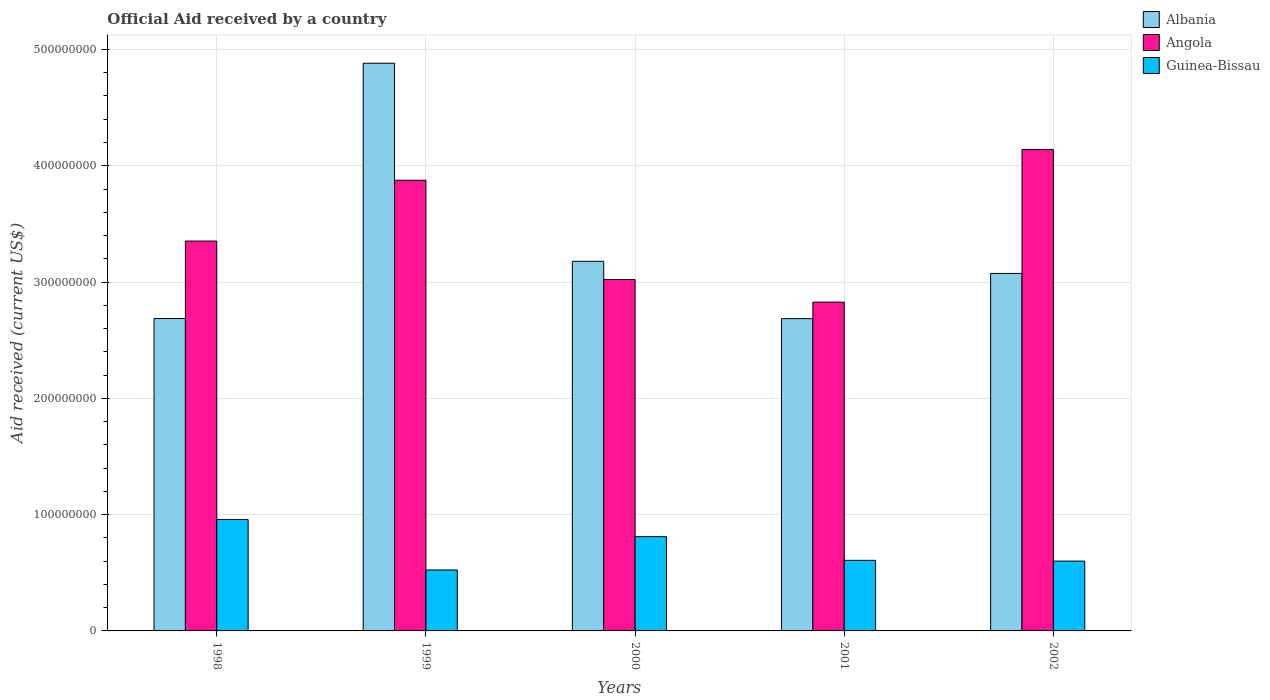Are the number of bars per tick equal to the number of legend labels?
Your answer should be compact. Yes. Are the number of bars on each tick of the X-axis equal?
Offer a terse response. Yes. What is the label of the 2nd group of bars from the left?
Give a very brief answer. 1999. What is the net official aid received in Angola in 2001?
Make the answer very short. 2.83e+08. Across all years, what is the maximum net official aid received in Angola?
Offer a very short reply. 4.14e+08. Across all years, what is the minimum net official aid received in Guinea-Bissau?
Offer a very short reply. 5.24e+07. In which year was the net official aid received in Angola maximum?
Your answer should be very brief. 2002. In which year was the net official aid received in Angola minimum?
Your response must be concise. 2001. What is the total net official aid received in Angola in the graph?
Offer a terse response. 1.72e+09. What is the difference between the net official aid received in Albania in 2001 and that in 2002?
Provide a short and direct response. -3.89e+07. What is the difference between the net official aid received in Albania in 2001 and the net official aid received in Angola in 1999?
Your response must be concise. -1.19e+08. What is the average net official aid received in Albania per year?
Make the answer very short. 3.30e+08. In the year 1998, what is the difference between the net official aid received in Angola and net official aid received in Albania?
Provide a succinct answer. 6.66e+07. What is the ratio of the net official aid received in Albania in 2000 to that in 2001?
Provide a short and direct response. 1.18. What is the difference between the highest and the second highest net official aid received in Angola?
Your answer should be very brief. 2.65e+07. What is the difference between the highest and the lowest net official aid received in Albania?
Offer a very short reply. 2.20e+08. In how many years, is the net official aid received in Albania greater than the average net official aid received in Albania taken over all years?
Keep it short and to the point. 1. Is the sum of the net official aid received in Guinea-Bissau in 1999 and 2001 greater than the maximum net official aid received in Albania across all years?
Offer a very short reply. No. What does the 1st bar from the left in 2000 represents?
Offer a terse response. Albania. What does the 3rd bar from the right in 2002 represents?
Provide a short and direct response. Albania. Is it the case that in every year, the sum of the net official aid received in Albania and net official aid received in Guinea-Bissau is greater than the net official aid received in Angola?
Ensure brevity in your answer.  No. How many bars are there?
Keep it short and to the point. 15. Does the graph contain any zero values?
Keep it short and to the point. No. Does the graph contain grids?
Make the answer very short. Yes. What is the title of the graph?
Offer a terse response. Official Aid received by a country. Does "Arab World" appear as one of the legend labels in the graph?
Provide a short and direct response. No. What is the label or title of the X-axis?
Make the answer very short. Years. What is the label or title of the Y-axis?
Your answer should be very brief. Aid received (current US$). What is the Aid received (current US$) in Albania in 1998?
Make the answer very short. 2.69e+08. What is the Aid received (current US$) in Angola in 1998?
Give a very brief answer. 3.35e+08. What is the Aid received (current US$) in Guinea-Bissau in 1998?
Provide a short and direct response. 9.58e+07. What is the Aid received (current US$) of Albania in 1999?
Provide a short and direct response. 4.88e+08. What is the Aid received (current US$) in Angola in 1999?
Keep it short and to the point. 3.88e+08. What is the Aid received (current US$) in Guinea-Bissau in 1999?
Provide a short and direct response. 5.24e+07. What is the Aid received (current US$) in Albania in 2000?
Keep it short and to the point. 3.18e+08. What is the Aid received (current US$) of Angola in 2000?
Offer a terse response. 3.02e+08. What is the Aid received (current US$) of Guinea-Bissau in 2000?
Provide a succinct answer. 8.11e+07. What is the Aid received (current US$) in Albania in 2001?
Make the answer very short. 2.69e+08. What is the Aid received (current US$) in Angola in 2001?
Keep it short and to the point. 2.83e+08. What is the Aid received (current US$) of Guinea-Bissau in 2001?
Provide a short and direct response. 6.07e+07. What is the Aid received (current US$) in Albania in 2002?
Your answer should be very brief. 3.07e+08. What is the Aid received (current US$) of Angola in 2002?
Offer a very short reply. 4.14e+08. What is the Aid received (current US$) of Guinea-Bissau in 2002?
Ensure brevity in your answer.  6.00e+07. Across all years, what is the maximum Aid received (current US$) in Albania?
Your answer should be very brief. 4.88e+08. Across all years, what is the maximum Aid received (current US$) in Angola?
Provide a short and direct response. 4.14e+08. Across all years, what is the maximum Aid received (current US$) of Guinea-Bissau?
Your response must be concise. 9.58e+07. Across all years, what is the minimum Aid received (current US$) in Albania?
Your answer should be very brief. 2.69e+08. Across all years, what is the minimum Aid received (current US$) of Angola?
Provide a succinct answer. 2.83e+08. Across all years, what is the minimum Aid received (current US$) in Guinea-Bissau?
Ensure brevity in your answer.  5.24e+07. What is the total Aid received (current US$) of Albania in the graph?
Offer a terse response. 1.65e+09. What is the total Aid received (current US$) of Angola in the graph?
Ensure brevity in your answer.  1.72e+09. What is the total Aid received (current US$) of Guinea-Bissau in the graph?
Your answer should be compact. 3.50e+08. What is the difference between the Aid received (current US$) of Albania in 1998 and that in 1999?
Your response must be concise. -2.20e+08. What is the difference between the Aid received (current US$) of Angola in 1998 and that in 1999?
Make the answer very short. -5.23e+07. What is the difference between the Aid received (current US$) of Guinea-Bissau in 1998 and that in 1999?
Provide a succinct answer. 4.34e+07. What is the difference between the Aid received (current US$) in Albania in 1998 and that in 2000?
Ensure brevity in your answer.  -4.92e+07. What is the difference between the Aid received (current US$) in Angola in 1998 and that in 2000?
Keep it short and to the point. 3.31e+07. What is the difference between the Aid received (current US$) in Guinea-Bissau in 1998 and that in 2000?
Your answer should be very brief. 1.48e+07. What is the difference between the Aid received (current US$) in Angola in 1998 and that in 2001?
Provide a short and direct response. 5.25e+07. What is the difference between the Aid received (current US$) of Guinea-Bissau in 1998 and that in 2001?
Ensure brevity in your answer.  3.51e+07. What is the difference between the Aid received (current US$) in Albania in 1998 and that in 2002?
Make the answer very short. -3.88e+07. What is the difference between the Aid received (current US$) of Angola in 1998 and that in 2002?
Your answer should be compact. -7.88e+07. What is the difference between the Aid received (current US$) in Guinea-Bissau in 1998 and that in 2002?
Keep it short and to the point. 3.58e+07. What is the difference between the Aid received (current US$) in Albania in 1999 and that in 2000?
Give a very brief answer. 1.70e+08. What is the difference between the Aid received (current US$) in Angola in 1999 and that in 2000?
Provide a short and direct response. 8.53e+07. What is the difference between the Aid received (current US$) of Guinea-Bissau in 1999 and that in 2000?
Provide a succinct answer. -2.86e+07. What is the difference between the Aid received (current US$) of Albania in 1999 and that in 2001?
Your response must be concise. 2.20e+08. What is the difference between the Aid received (current US$) in Angola in 1999 and that in 2001?
Offer a terse response. 1.05e+08. What is the difference between the Aid received (current US$) in Guinea-Bissau in 1999 and that in 2001?
Your answer should be very brief. -8.28e+06. What is the difference between the Aid received (current US$) of Albania in 1999 and that in 2002?
Offer a very short reply. 1.81e+08. What is the difference between the Aid received (current US$) in Angola in 1999 and that in 2002?
Provide a short and direct response. -2.65e+07. What is the difference between the Aid received (current US$) in Guinea-Bissau in 1999 and that in 2002?
Your response must be concise. -7.62e+06. What is the difference between the Aid received (current US$) in Albania in 2000 and that in 2001?
Ensure brevity in your answer.  4.93e+07. What is the difference between the Aid received (current US$) of Angola in 2000 and that in 2001?
Offer a terse response. 1.95e+07. What is the difference between the Aid received (current US$) in Guinea-Bissau in 2000 and that in 2001?
Make the answer very short. 2.04e+07. What is the difference between the Aid received (current US$) in Albania in 2000 and that in 2002?
Make the answer very short. 1.04e+07. What is the difference between the Aid received (current US$) of Angola in 2000 and that in 2002?
Give a very brief answer. -1.12e+08. What is the difference between the Aid received (current US$) in Guinea-Bissau in 2000 and that in 2002?
Give a very brief answer. 2.10e+07. What is the difference between the Aid received (current US$) of Albania in 2001 and that in 2002?
Offer a terse response. -3.89e+07. What is the difference between the Aid received (current US$) in Angola in 2001 and that in 2002?
Give a very brief answer. -1.31e+08. What is the difference between the Aid received (current US$) of Guinea-Bissau in 2001 and that in 2002?
Keep it short and to the point. 6.60e+05. What is the difference between the Aid received (current US$) in Albania in 1998 and the Aid received (current US$) in Angola in 1999?
Give a very brief answer. -1.19e+08. What is the difference between the Aid received (current US$) of Albania in 1998 and the Aid received (current US$) of Guinea-Bissau in 1999?
Provide a succinct answer. 2.16e+08. What is the difference between the Aid received (current US$) in Angola in 1998 and the Aid received (current US$) in Guinea-Bissau in 1999?
Ensure brevity in your answer.  2.83e+08. What is the difference between the Aid received (current US$) of Albania in 1998 and the Aid received (current US$) of Angola in 2000?
Keep it short and to the point. -3.36e+07. What is the difference between the Aid received (current US$) of Albania in 1998 and the Aid received (current US$) of Guinea-Bissau in 2000?
Ensure brevity in your answer.  1.88e+08. What is the difference between the Aid received (current US$) of Angola in 1998 and the Aid received (current US$) of Guinea-Bissau in 2000?
Offer a very short reply. 2.54e+08. What is the difference between the Aid received (current US$) of Albania in 1998 and the Aid received (current US$) of Angola in 2001?
Ensure brevity in your answer.  -1.41e+07. What is the difference between the Aid received (current US$) of Albania in 1998 and the Aid received (current US$) of Guinea-Bissau in 2001?
Your response must be concise. 2.08e+08. What is the difference between the Aid received (current US$) in Angola in 1998 and the Aid received (current US$) in Guinea-Bissau in 2001?
Offer a very short reply. 2.75e+08. What is the difference between the Aid received (current US$) in Albania in 1998 and the Aid received (current US$) in Angola in 2002?
Provide a short and direct response. -1.45e+08. What is the difference between the Aid received (current US$) in Albania in 1998 and the Aid received (current US$) in Guinea-Bissau in 2002?
Give a very brief answer. 2.09e+08. What is the difference between the Aid received (current US$) of Angola in 1998 and the Aid received (current US$) of Guinea-Bissau in 2002?
Ensure brevity in your answer.  2.75e+08. What is the difference between the Aid received (current US$) of Albania in 1999 and the Aid received (current US$) of Angola in 2000?
Ensure brevity in your answer.  1.86e+08. What is the difference between the Aid received (current US$) in Albania in 1999 and the Aid received (current US$) in Guinea-Bissau in 2000?
Your answer should be very brief. 4.07e+08. What is the difference between the Aid received (current US$) in Angola in 1999 and the Aid received (current US$) in Guinea-Bissau in 2000?
Provide a succinct answer. 3.06e+08. What is the difference between the Aid received (current US$) in Albania in 1999 and the Aid received (current US$) in Angola in 2001?
Your response must be concise. 2.05e+08. What is the difference between the Aid received (current US$) in Albania in 1999 and the Aid received (current US$) in Guinea-Bissau in 2001?
Offer a very short reply. 4.27e+08. What is the difference between the Aid received (current US$) in Angola in 1999 and the Aid received (current US$) in Guinea-Bissau in 2001?
Provide a short and direct response. 3.27e+08. What is the difference between the Aid received (current US$) of Albania in 1999 and the Aid received (current US$) of Angola in 2002?
Your response must be concise. 7.41e+07. What is the difference between the Aid received (current US$) of Albania in 1999 and the Aid received (current US$) of Guinea-Bissau in 2002?
Provide a succinct answer. 4.28e+08. What is the difference between the Aid received (current US$) of Angola in 1999 and the Aid received (current US$) of Guinea-Bissau in 2002?
Provide a succinct answer. 3.28e+08. What is the difference between the Aid received (current US$) of Albania in 2000 and the Aid received (current US$) of Angola in 2001?
Your answer should be compact. 3.51e+07. What is the difference between the Aid received (current US$) of Albania in 2000 and the Aid received (current US$) of Guinea-Bissau in 2001?
Make the answer very short. 2.57e+08. What is the difference between the Aid received (current US$) in Angola in 2000 and the Aid received (current US$) in Guinea-Bissau in 2001?
Your response must be concise. 2.42e+08. What is the difference between the Aid received (current US$) in Albania in 2000 and the Aid received (current US$) in Angola in 2002?
Give a very brief answer. -9.62e+07. What is the difference between the Aid received (current US$) of Albania in 2000 and the Aid received (current US$) of Guinea-Bissau in 2002?
Your answer should be compact. 2.58e+08. What is the difference between the Aid received (current US$) of Angola in 2000 and the Aid received (current US$) of Guinea-Bissau in 2002?
Ensure brevity in your answer.  2.42e+08. What is the difference between the Aid received (current US$) of Albania in 2001 and the Aid received (current US$) of Angola in 2002?
Provide a succinct answer. -1.46e+08. What is the difference between the Aid received (current US$) in Albania in 2001 and the Aid received (current US$) in Guinea-Bissau in 2002?
Provide a short and direct response. 2.08e+08. What is the difference between the Aid received (current US$) of Angola in 2001 and the Aid received (current US$) of Guinea-Bissau in 2002?
Give a very brief answer. 2.23e+08. What is the average Aid received (current US$) in Albania per year?
Offer a terse response. 3.30e+08. What is the average Aid received (current US$) in Angola per year?
Provide a short and direct response. 3.44e+08. What is the average Aid received (current US$) in Guinea-Bissau per year?
Give a very brief answer. 7.00e+07. In the year 1998, what is the difference between the Aid received (current US$) in Albania and Aid received (current US$) in Angola?
Your answer should be very brief. -6.66e+07. In the year 1998, what is the difference between the Aid received (current US$) of Albania and Aid received (current US$) of Guinea-Bissau?
Give a very brief answer. 1.73e+08. In the year 1998, what is the difference between the Aid received (current US$) of Angola and Aid received (current US$) of Guinea-Bissau?
Provide a short and direct response. 2.39e+08. In the year 1999, what is the difference between the Aid received (current US$) of Albania and Aid received (current US$) of Angola?
Make the answer very short. 1.01e+08. In the year 1999, what is the difference between the Aid received (current US$) in Albania and Aid received (current US$) in Guinea-Bissau?
Offer a very short reply. 4.36e+08. In the year 1999, what is the difference between the Aid received (current US$) in Angola and Aid received (current US$) in Guinea-Bissau?
Your response must be concise. 3.35e+08. In the year 2000, what is the difference between the Aid received (current US$) in Albania and Aid received (current US$) in Angola?
Provide a succinct answer. 1.56e+07. In the year 2000, what is the difference between the Aid received (current US$) in Albania and Aid received (current US$) in Guinea-Bissau?
Make the answer very short. 2.37e+08. In the year 2000, what is the difference between the Aid received (current US$) in Angola and Aid received (current US$) in Guinea-Bissau?
Ensure brevity in your answer.  2.21e+08. In the year 2001, what is the difference between the Aid received (current US$) of Albania and Aid received (current US$) of Angola?
Give a very brief answer. -1.42e+07. In the year 2001, what is the difference between the Aid received (current US$) in Albania and Aid received (current US$) in Guinea-Bissau?
Offer a very short reply. 2.08e+08. In the year 2001, what is the difference between the Aid received (current US$) in Angola and Aid received (current US$) in Guinea-Bissau?
Your response must be concise. 2.22e+08. In the year 2002, what is the difference between the Aid received (current US$) of Albania and Aid received (current US$) of Angola?
Make the answer very short. -1.07e+08. In the year 2002, what is the difference between the Aid received (current US$) of Albania and Aid received (current US$) of Guinea-Bissau?
Your answer should be compact. 2.47e+08. In the year 2002, what is the difference between the Aid received (current US$) of Angola and Aid received (current US$) of Guinea-Bissau?
Your response must be concise. 3.54e+08. What is the ratio of the Aid received (current US$) in Albania in 1998 to that in 1999?
Keep it short and to the point. 0.55. What is the ratio of the Aid received (current US$) in Angola in 1998 to that in 1999?
Ensure brevity in your answer.  0.87. What is the ratio of the Aid received (current US$) of Guinea-Bissau in 1998 to that in 1999?
Offer a very short reply. 1.83. What is the ratio of the Aid received (current US$) in Albania in 1998 to that in 2000?
Offer a very short reply. 0.85. What is the ratio of the Aid received (current US$) of Angola in 1998 to that in 2000?
Keep it short and to the point. 1.11. What is the ratio of the Aid received (current US$) in Guinea-Bissau in 1998 to that in 2000?
Offer a terse response. 1.18. What is the ratio of the Aid received (current US$) of Albania in 1998 to that in 2001?
Offer a terse response. 1. What is the ratio of the Aid received (current US$) of Angola in 1998 to that in 2001?
Your answer should be compact. 1.19. What is the ratio of the Aid received (current US$) in Guinea-Bissau in 1998 to that in 2001?
Your answer should be compact. 1.58. What is the ratio of the Aid received (current US$) of Albania in 1998 to that in 2002?
Your answer should be very brief. 0.87. What is the ratio of the Aid received (current US$) in Angola in 1998 to that in 2002?
Ensure brevity in your answer.  0.81. What is the ratio of the Aid received (current US$) in Guinea-Bissau in 1998 to that in 2002?
Your answer should be compact. 1.6. What is the ratio of the Aid received (current US$) in Albania in 1999 to that in 2000?
Offer a terse response. 1.54. What is the ratio of the Aid received (current US$) of Angola in 1999 to that in 2000?
Provide a succinct answer. 1.28. What is the ratio of the Aid received (current US$) in Guinea-Bissau in 1999 to that in 2000?
Ensure brevity in your answer.  0.65. What is the ratio of the Aid received (current US$) of Albania in 1999 to that in 2001?
Offer a terse response. 1.82. What is the ratio of the Aid received (current US$) in Angola in 1999 to that in 2001?
Offer a terse response. 1.37. What is the ratio of the Aid received (current US$) of Guinea-Bissau in 1999 to that in 2001?
Your response must be concise. 0.86. What is the ratio of the Aid received (current US$) of Albania in 1999 to that in 2002?
Offer a very short reply. 1.59. What is the ratio of the Aid received (current US$) in Angola in 1999 to that in 2002?
Offer a very short reply. 0.94. What is the ratio of the Aid received (current US$) in Guinea-Bissau in 1999 to that in 2002?
Your response must be concise. 0.87. What is the ratio of the Aid received (current US$) in Albania in 2000 to that in 2001?
Provide a short and direct response. 1.18. What is the ratio of the Aid received (current US$) in Angola in 2000 to that in 2001?
Give a very brief answer. 1.07. What is the ratio of the Aid received (current US$) of Guinea-Bissau in 2000 to that in 2001?
Provide a succinct answer. 1.34. What is the ratio of the Aid received (current US$) of Albania in 2000 to that in 2002?
Your answer should be compact. 1.03. What is the ratio of the Aid received (current US$) in Angola in 2000 to that in 2002?
Offer a very short reply. 0.73. What is the ratio of the Aid received (current US$) in Guinea-Bissau in 2000 to that in 2002?
Make the answer very short. 1.35. What is the ratio of the Aid received (current US$) in Albania in 2001 to that in 2002?
Offer a terse response. 0.87. What is the ratio of the Aid received (current US$) in Angola in 2001 to that in 2002?
Keep it short and to the point. 0.68. What is the difference between the highest and the second highest Aid received (current US$) of Albania?
Provide a short and direct response. 1.70e+08. What is the difference between the highest and the second highest Aid received (current US$) of Angola?
Your answer should be very brief. 2.65e+07. What is the difference between the highest and the second highest Aid received (current US$) of Guinea-Bissau?
Offer a very short reply. 1.48e+07. What is the difference between the highest and the lowest Aid received (current US$) in Albania?
Make the answer very short. 2.20e+08. What is the difference between the highest and the lowest Aid received (current US$) of Angola?
Give a very brief answer. 1.31e+08. What is the difference between the highest and the lowest Aid received (current US$) in Guinea-Bissau?
Ensure brevity in your answer.  4.34e+07. 